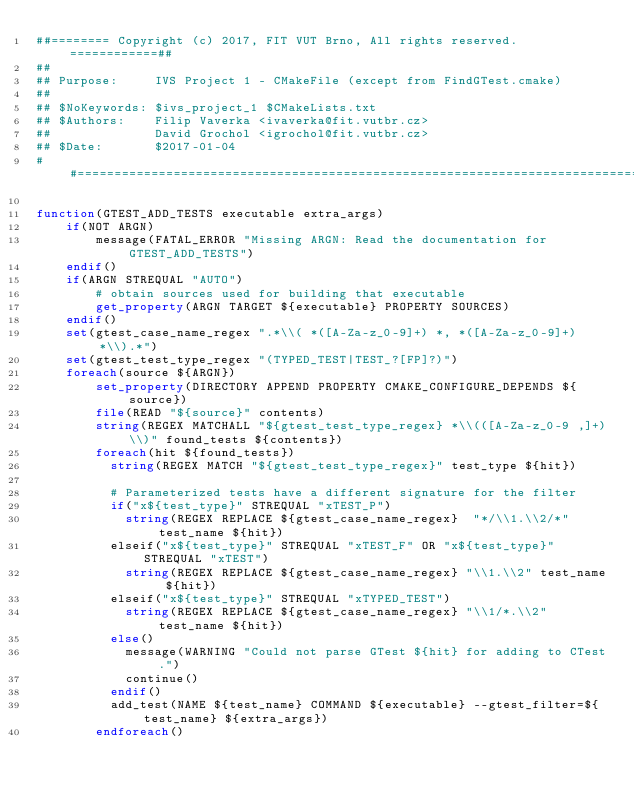Convert code to text. <code><loc_0><loc_0><loc_500><loc_500><_CMake_>##======== Copyright (c) 2017, FIT VUT Brno, All rights reserved. ============##
##
## Purpose:     IVS Project 1 - CMakeFile (except from FindGTest.cmake)
##
## $NoKeywords: $ivs_project_1 $CMakeLists.txt
## $Authors:    Filip Vaverka <ivaverka@fit.vutbr.cz>
##              David Grochol <igrochol@fit.vutbr.cz>
## $Date:       $2017-01-04
##============================================================================##

function(GTEST_ADD_TESTS executable extra_args)
    if(NOT ARGN)
        message(FATAL_ERROR "Missing ARGN: Read the documentation for GTEST_ADD_TESTS")
    endif()
    if(ARGN STREQUAL "AUTO")
        # obtain sources used for building that executable
        get_property(ARGN TARGET ${executable} PROPERTY SOURCES)
    endif()
    set(gtest_case_name_regex ".*\\( *([A-Za-z_0-9]+) *, *([A-Za-z_0-9]+) *\\).*")
    set(gtest_test_type_regex "(TYPED_TEST|TEST_?[FP]?)")
    foreach(source ${ARGN})
        set_property(DIRECTORY APPEND PROPERTY CMAKE_CONFIGURE_DEPENDS ${source})
        file(READ "${source}" contents)
        string(REGEX MATCHALL "${gtest_test_type_regex} *\\(([A-Za-z_0-9 ,]+)\\)" found_tests ${contents})
        foreach(hit ${found_tests})
          string(REGEX MATCH "${gtest_test_type_regex}" test_type ${hit})

          # Parameterized tests have a different signature for the filter
          if("x${test_type}" STREQUAL "xTEST_P")
            string(REGEX REPLACE ${gtest_case_name_regex}  "*/\\1.\\2/*" test_name ${hit})
          elseif("x${test_type}" STREQUAL "xTEST_F" OR "x${test_type}" STREQUAL "xTEST")
            string(REGEX REPLACE ${gtest_case_name_regex} "\\1.\\2" test_name ${hit})
          elseif("x${test_type}" STREQUAL "xTYPED_TEST")
            string(REGEX REPLACE ${gtest_case_name_regex} "\\1/*.\\2" test_name ${hit})
          else()
            message(WARNING "Could not parse GTest ${hit} for adding to CTest.")
            continue()
          endif()
          add_test(NAME ${test_name} COMMAND ${executable} --gtest_filter=${test_name} ${extra_args})
        endforeach()</code> 